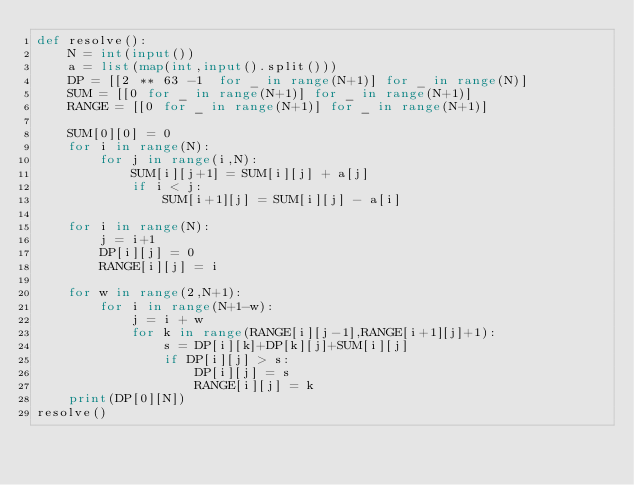Convert code to text. <code><loc_0><loc_0><loc_500><loc_500><_Python_>def resolve():
    N = int(input())
    a = list(map(int,input().split()))
    DP = [[2 ** 63 -1  for _ in range(N+1)] for _ in range(N)]
    SUM = [[0 for _ in range(N+1)] for _ in range(N+1)]
    RANGE = [[0 for _ in range(N+1)] for _ in range(N+1)]

    SUM[0][0] = 0
    for i in range(N):
        for j in range(i,N):
            SUM[i][j+1] = SUM[i][j] + a[j]
            if i < j:
                SUM[i+1][j] = SUM[i][j] - a[i]

    for i in range(N):
        j = i+1
        DP[i][j] = 0
        RANGE[i][j] = i

    for w in range(2,N+1):
        for i in range(N+1-w):
            j = i + w
            for k in range(RANGE[i][j-1],RANGE[i+1][j]+1):
                s = DP[i][k]+DP[k][j]+SUM[i][j]
                if DP[i][j] > s:
                    DP[i][j] = s
                    RANGE[i][j] = k
    print(DP[0][N])
resolve()</code> 